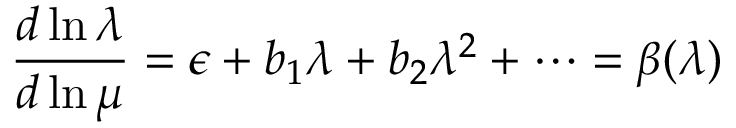<formula> <loc_0><loc_0><loc_500><loc_500>\frac { d \ln \lambda } { d \ln \mu } = \epsilon + b _ { 1 } \lambda + b _ { 2 } \lambda ^ { 2 } + \dots = \beta ( \lambda )</formula> 